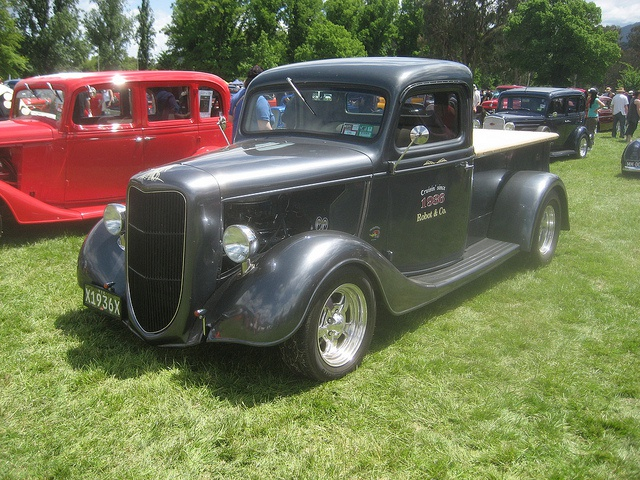Describe the objects in this image and their specific colors. I can see truck in darkgreen, gray, black, and darkgray tones, car in darkgreen, brown, salmon, and maroon tones, people in darkgreen, gray, and lightblue tones, people in darkgreen, gray, black, and teal tones, and people in darkgreen, darkgray, gray, purple, and black tones in this image. 